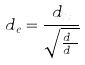<formula> <loc_0><loc_0><loc_500><loc_500>d _ { e } = \frac { d _ { x } } { \sqrt { \frac { d _ { x } } { d _ { a } } } }</formula> 